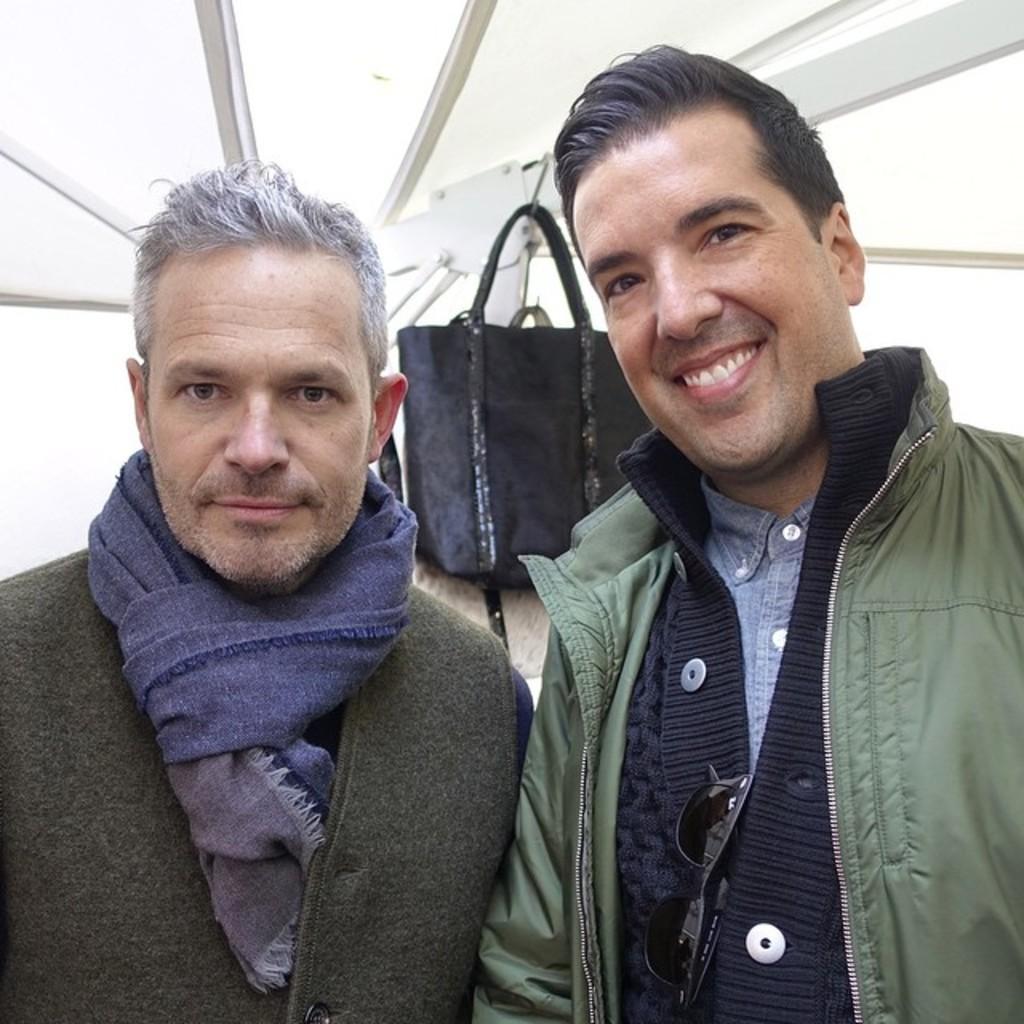How would you summarize this image in a sentence or two? In this picture we can see two men are standing and smiling. There is a bag hung to a rod. 